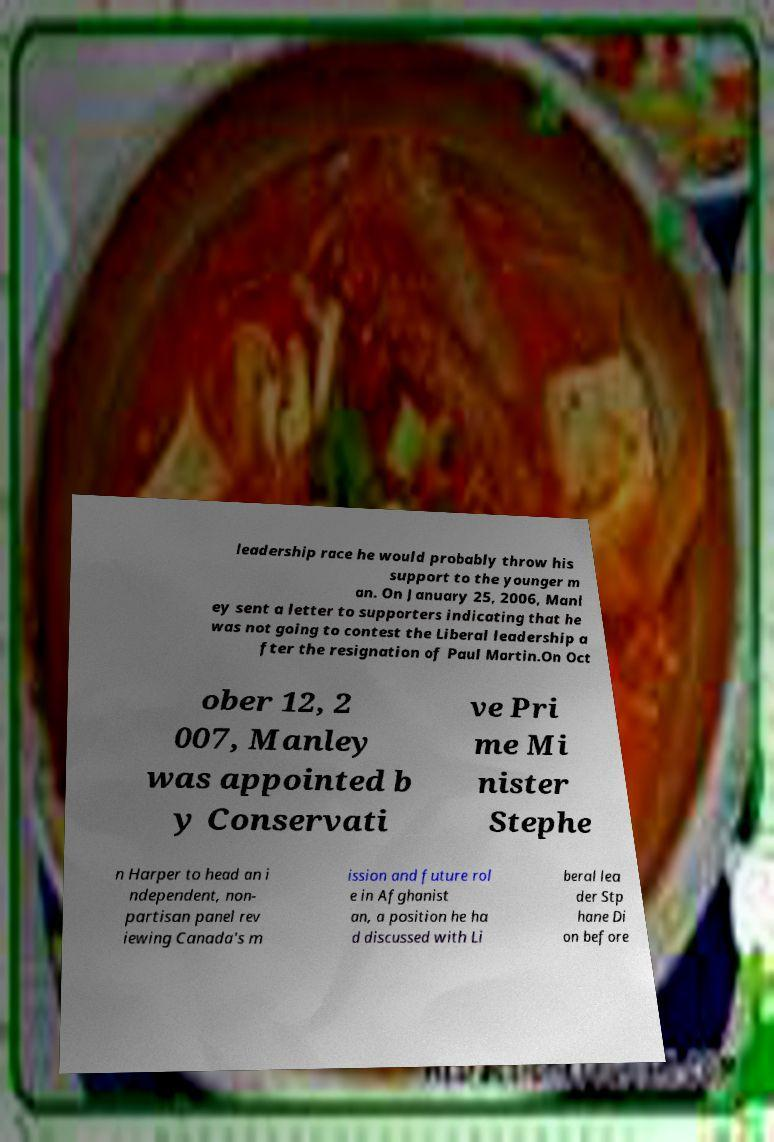Can you read and provide the text displayed in the image?This photo seems to have some interesting text. Can you extract and type it out for me? leadership race he would probably throw his support to the younger m an. On January 25, 2006, Manl ey sent a letter to supporters indicating that he was not going to contest the Liberal leadership a fter the resignation of Paul Martin.On Oct ober 12, 2 007, Manley was appointed b y Conservati ve Pri me Mi nister Stephe n Harper to head an i ndependent, non- partisan panel rev iewing Canada's m ission and future rol e in Afghanist an, a position he ha d discussed with Li beral lea der Stp hane Di on before 